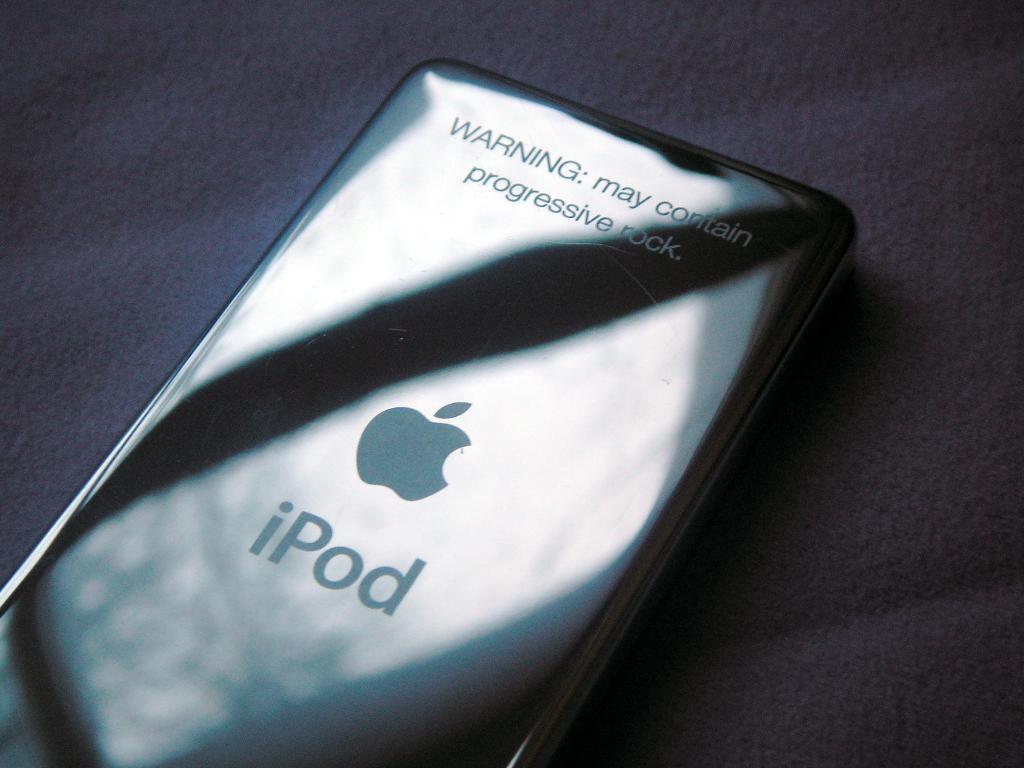What might the ipod contain?
Provide a succinct answer. Progressive rock. 